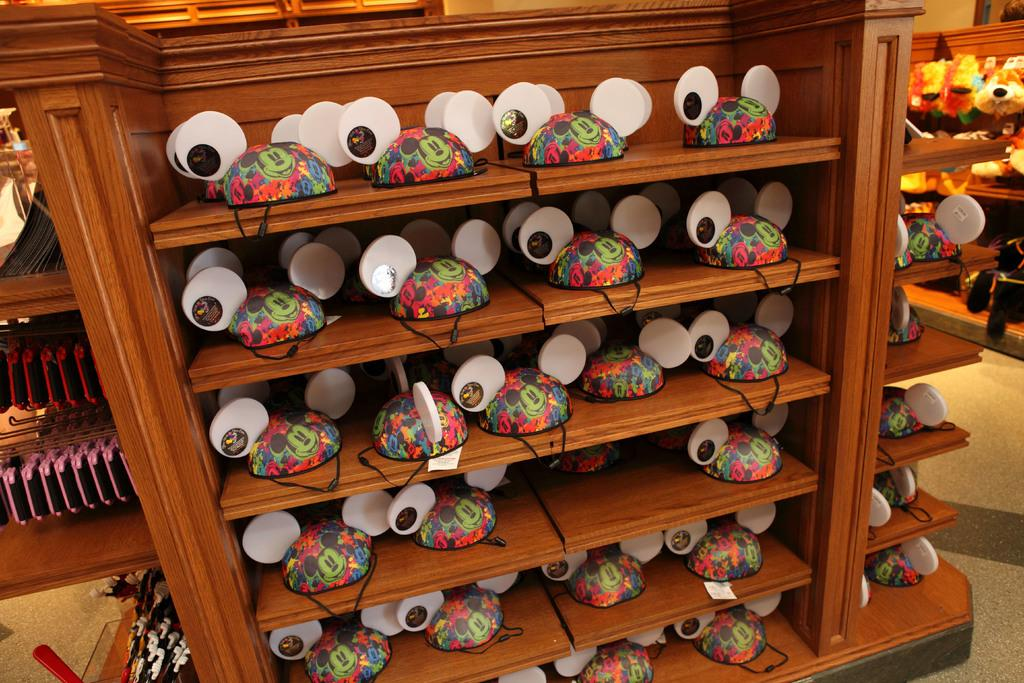What type of bicycle helmets are in the image? The bicycle helmets in the image are in the shape of Mickey Mouse. How are the helmets arranged in the image? The helmets are in racks. What can be seen in the background of the image? There are objects visible in the background of the image, but their specific details are not mentioned in the provided facts. How many children are riding dinosaurs in the image? There are no children or dinosaurs present in the image; it features Mickey Mouse-shaped bicycle helmets in racks. What is the condition of the person's throat in the image? There is no person or mention of a throat in the image. 